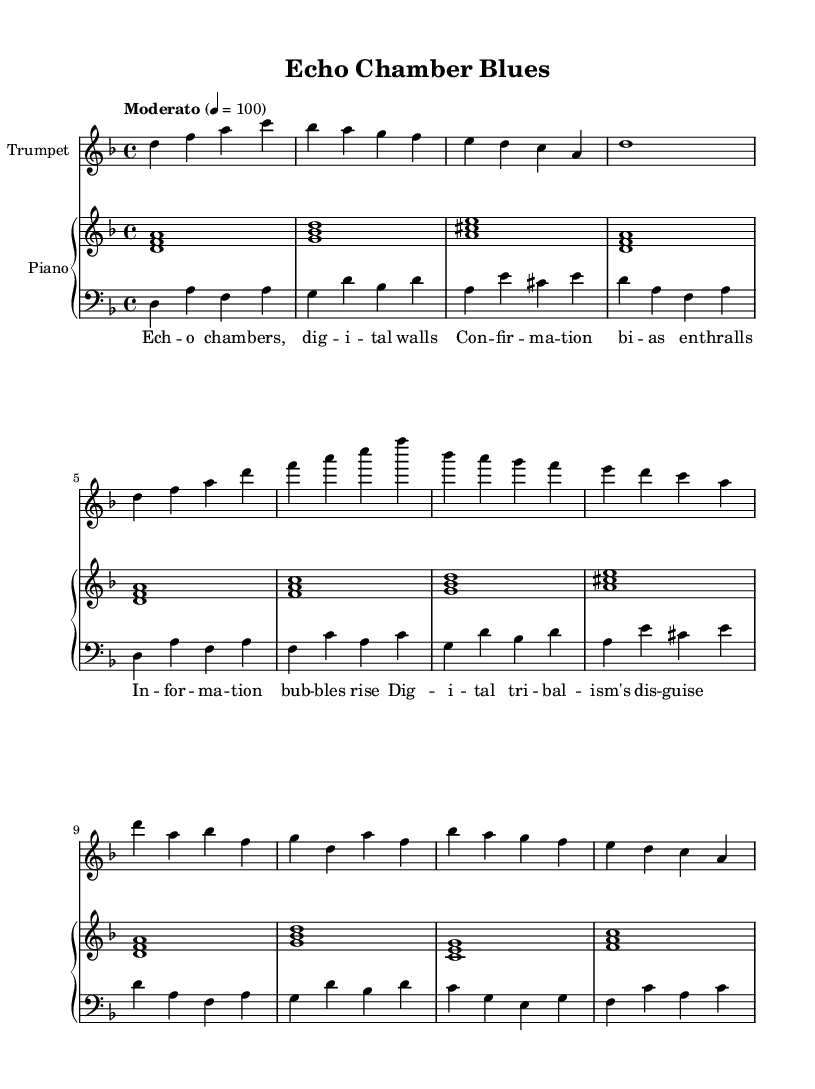What is the key signature of this piece? The key signature is D minor, which has one flat (B flat). This can be verified by looking at the key signature at the beginning of the staff.
Answer: D minor What is the time signature of this piece? The time signature shown at the beginning of the staff is 4/4, meaning there are four beats per measure and the quarter note gets one beat.
Answer: 4/4 What is the tempo marking for this composition? The tempo is indicated as "Moderato" with a metronome marking of 4 = 100, suggesting a moderate speed of 100 beats per minute.
Answer: Moderato How many measures are in the trumpet part? The trumpet part shows a total of 6 measures, which can be counted by examining the bar lines separating the music notes.
Answer: 6 What is the main theme of the lyrics? The lyrics focus on themes of digital echo chambers and the implications of social media, specifically discussing concepts like confirmation bias and tribalism, which is evident from the content of the lines.
Answer: Digital echo chambers Identify the type of harmony present in the piano part. The harmony in the piano part consists of simple triads and seventh chords, which contribute to the overall harmonic texture of the piece. This can be determined by analyzing the chords written in the staff.
Answer: Triads What cultural influences can be inferred from this work's genre? The piece blends Afro-Cuban jazz elements with spoken word poetry, informing us about the influence of African rhythms and Latin musical styles intertwined with contemporary issues related to social media.
Answer: Afro-Cuban jazz 